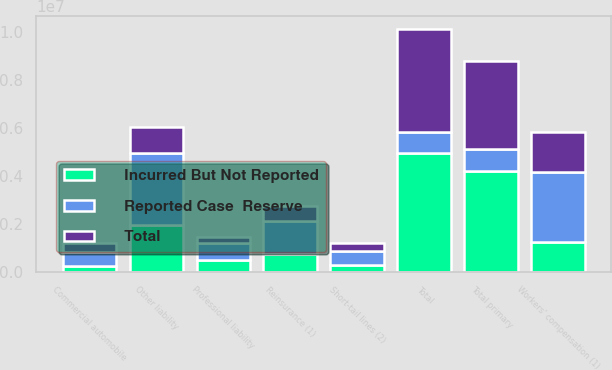Convert chart. <chart><loc_0><loc_0><loc_500><loc_500><stacked_bar_chart><ecel><fcel>Other liability<fcel>Workers' compensation (1)<fcel>Professional liability<fcel>Commercial automobile<fcel>Short-tail lines (2)<fcel>Total primary<fcel>Reinsurance (1)<fcel>Total<nl><fcel>Total<fcel>1.07964e+06<fcel>1.65573e+06<fcel>256783<fcel>352208<fcel>317375<fcel>3.66173e+06<fcel>631666<fcel>4.2934e+06<nl><fcel>Incurred But Not Reported<fcel>1.94764e+06<fcel>1.26351e+06<fcel>478796<fcel>242071<fcel>282448<fcel>4.21446e+06<fcel>737013<fcel>4.95147e+06<nl><fcel>Reported Case  Reserve<fcel>3.02728e+06<fcel>2.91923e+06<fcel>735579<fcel>594279<fcel>599823<fcel>908327<fcel>1.36868e+06<fcel>908327<nl></chart> 